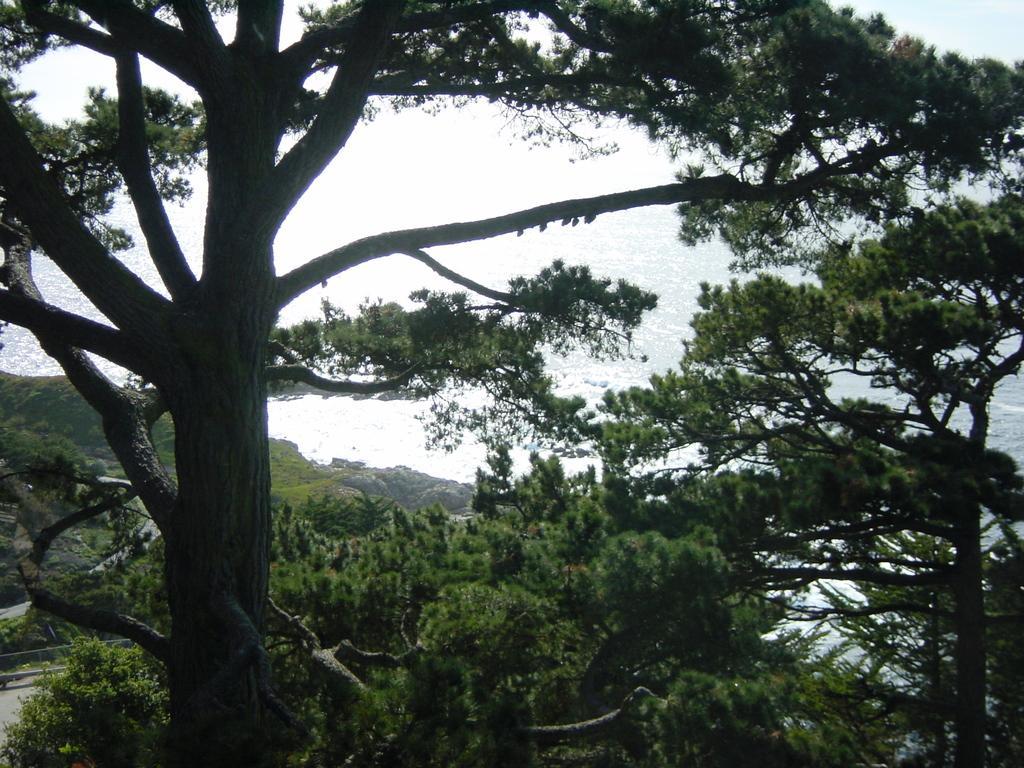Can you describe this image briefly? In this image, I can see the trees with branches and leaves. This looks like the water. 